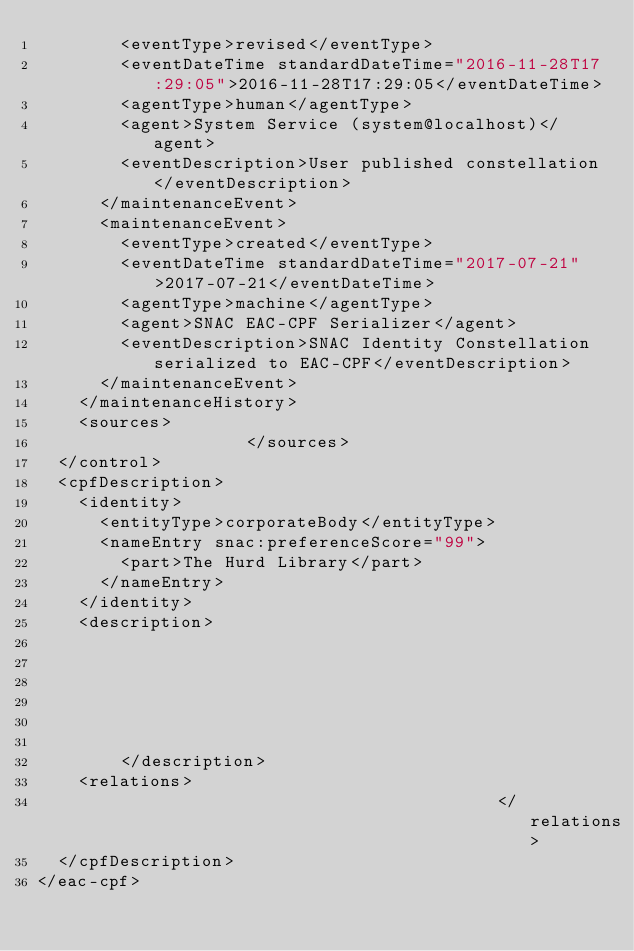<code> <loc_0><loc_0><loc_500><loc_500><_XML_>        <eventType>revised</eventType>
        <eventDateTime standardDateTime="2016-11-28T17:29:05">2016-11-28T17:29:05</eventDateTime>
        <agentType>human</agentType>
        <agent>System Service (system@localhost)</agent>
        <eventDescription>User published constellation</eventDescription>
      </maintenanceEvent>
      <maintenanceEvent>
        <eventType>created</eventType>
        <eventDateTime standardDateTime="2017-07-21">2017-07-21</eventDateTime>
        <agentType>machine</agentType>
        <agent>SNAC EAC-CPF Serializer</agent>
        <eventDescription>SNAC Identity Constellation serialized to EAC-CPF</eventDescription>
      </maintenanceEvent>
    </maintenanceHistory>
    <sources>
                    </sources>
  </control>
  <cpfDescription>
    <identity>
      <entityType>corporateBody</entityType>
      <nameEntry snac:preferenceScore="99">
        <part>The Hurd Library</part>
      </nameEntry>
    </identity>
    <description>
                                                                                                            
            
            
            
            
                        
        </description>
    <relations>
                                            </relations>
  </cpfDescription>
</eac-cpf>
</code> 